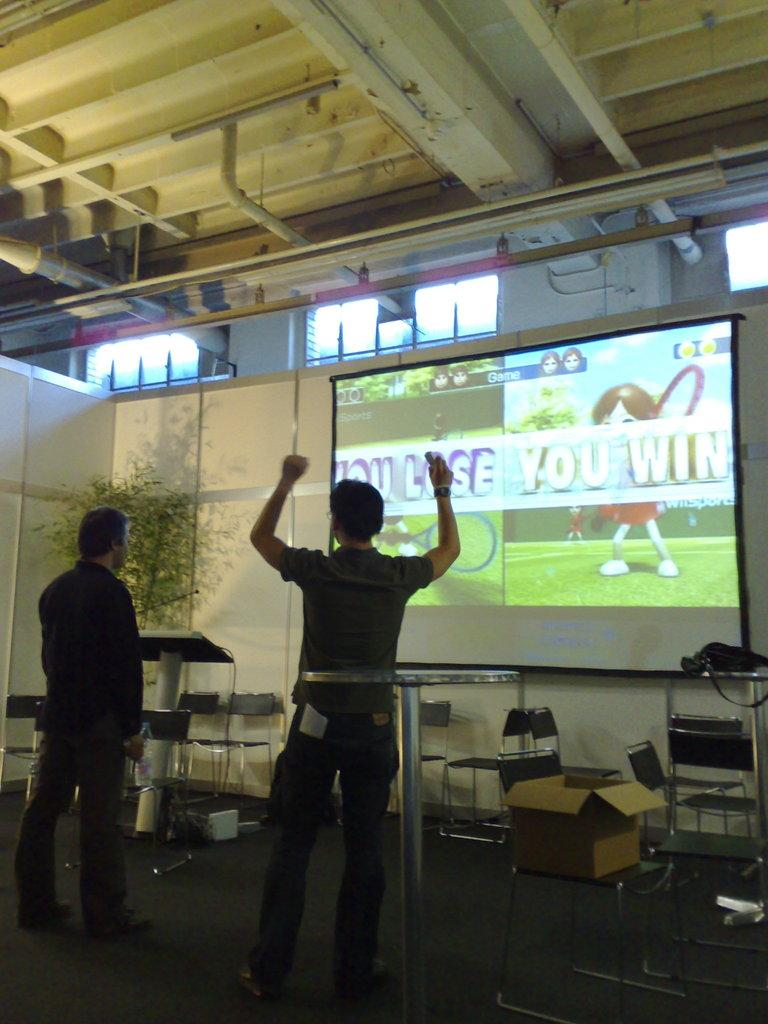<image>
Create a compact narrative representing the image presented. The man on the right won the game. 